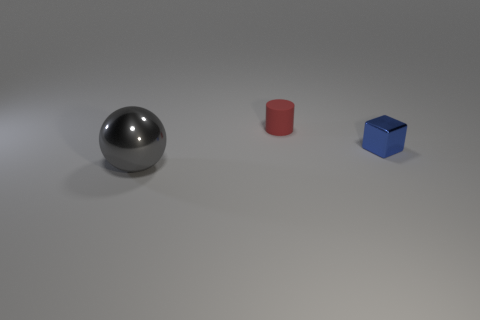Are there any other things that have the same material as the tiny red cylinder?
Provide a succinct answer. No. Are there any cubes that have the same color as the tiny cylinder?
Provide a succinct answer. No. There is a cylinder that is the same size as the blue cube; what color is it?
Your answer should be very brief. Red. Is the material of the object in front of the small blue metallic thing the same as the block?
Keep it short and to the point. Yes. There is a shiny thing left of the shiny thing that is behind the large object; are there any small red rubber objects that are on the right side of it?
Your response must be concise. Yes. The thing in front of the thing that is to the right of the red cylinder is what shape?
Offer a terse response. Sphere. What size is the shiny object that is behind the metallic thing that is in front of the shiny object that is right of the big gray metal thing?
Offer a very short reply. Small. Does the blue shiny block have the same size as the gray thing?
Ensure brevity in your answer.  No. What is the material of the tiny thing right of the cylinder?
Give a very brief answer. Metal. How many other things are the same shape as the large gray object?
Your response must be concise. 0. 